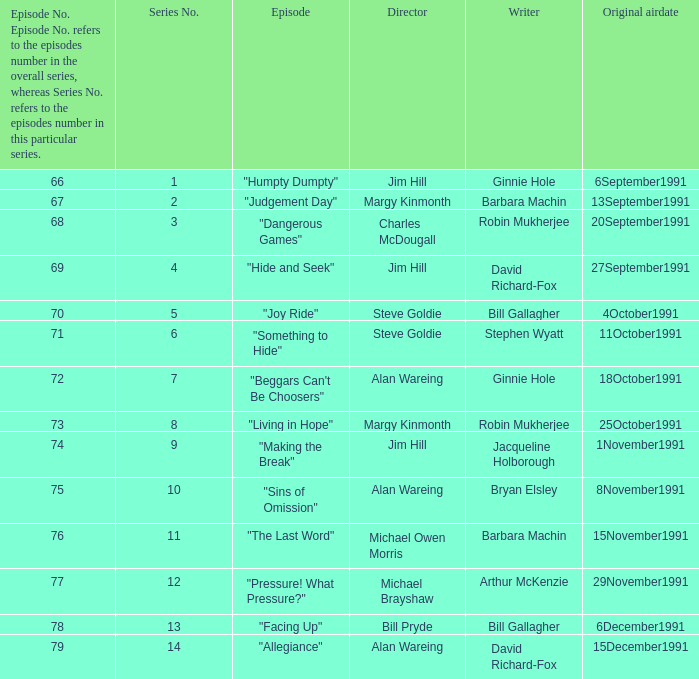Name the least series number for episode number being 78 13.0. 